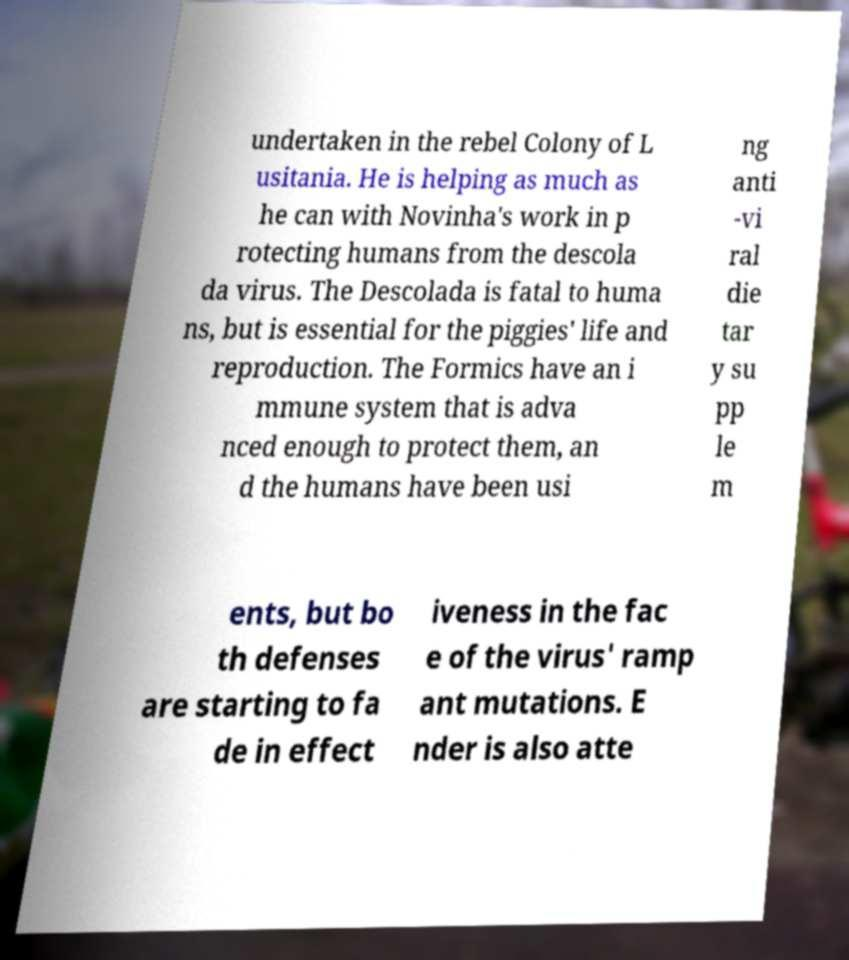Please identify and transcribe the text found in this image. undertaken in the rebel Colony of L usitania. He is helping as much as he can with Novinha's work in p rotecting humans from the descola da virus. The Descolada is fatal to huma ns, but is essential for the piggies' life and reproduction. The Formics have an i mmune system that is adva nced enough to protect them, an d the humans have been usi ng anti -vi ral die tar y su pp le m ents, but bo th defenses are starting to fa de in effect iveness in the fac e of the virus' ramp ant mutations. E nder is also atte 